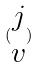<formula> <loc_0><loc_0><loc_500><loc_500>( \begin{matrix} j \\ v \end{matrix} )</formula> 